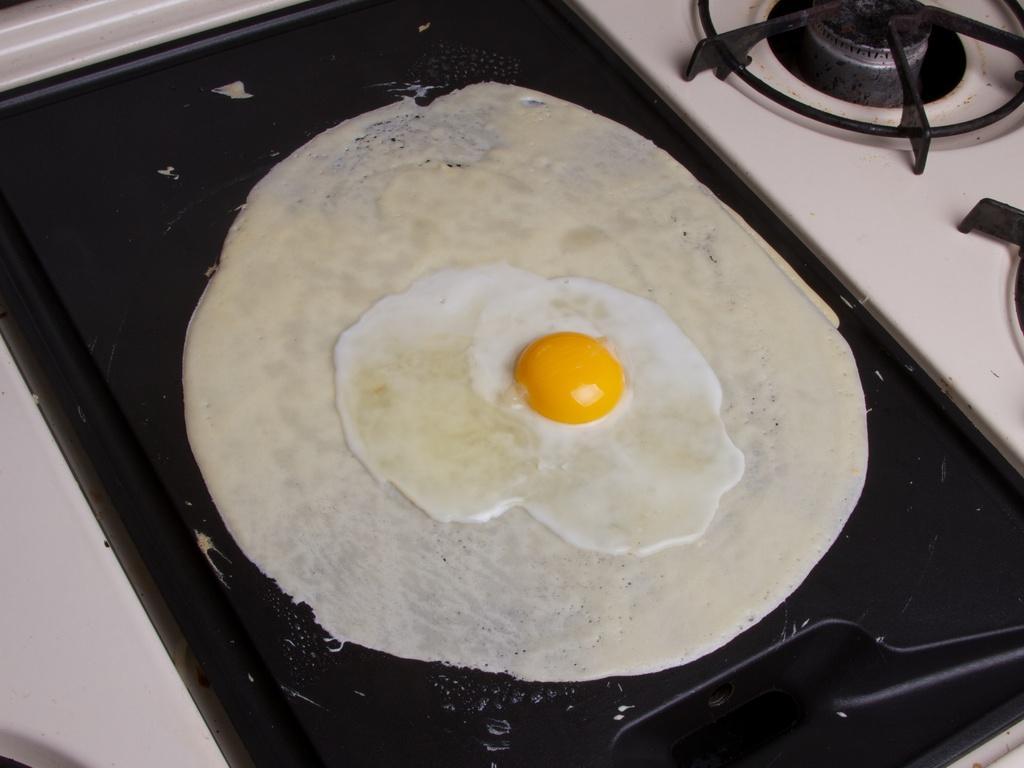Could you give a brief overview of what you see in this image? In this image, we can see a food item on the surface and we can see a gas stove. 